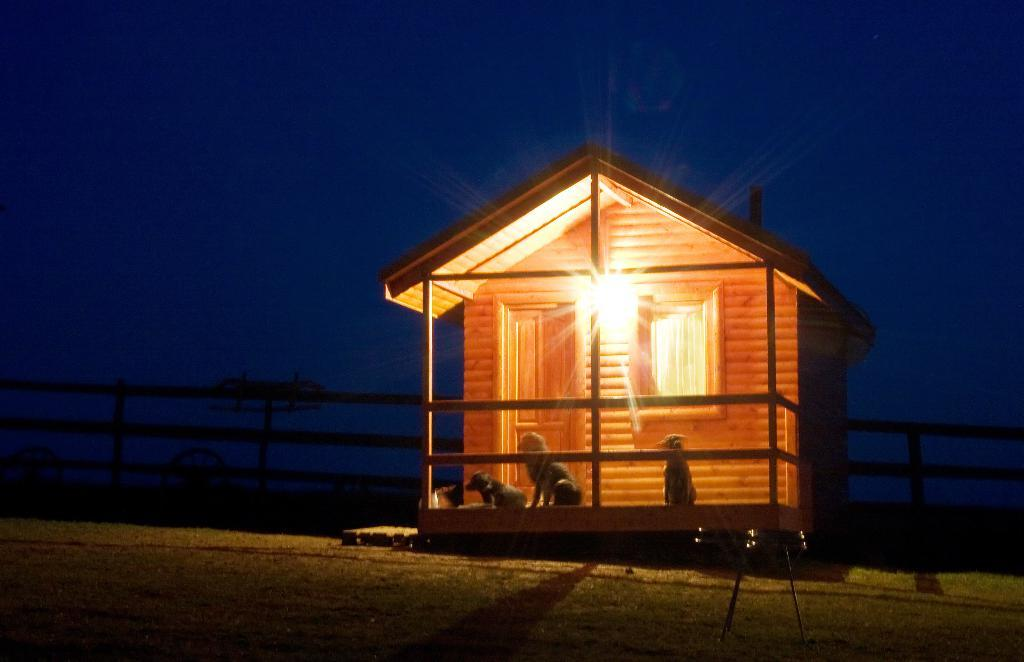What type of house is in the picture? There is a wooden house in the picture. Is there any lighting attached to the house? Yes, there is a light attached to the house. How many dogs are in front of the house? There are three dogs in front of the house. What can be seen in the background of the picture? There is a fence in the background of the picture. What type of dinner is being served on the street in the image? There is no dinner or street present in the image; it features a wooden house with a light, three dogs, and a fence in the background. 